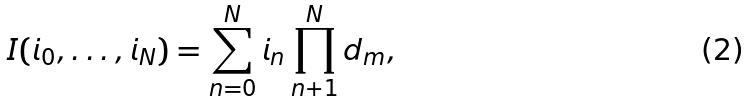Convert formula to latex. <formula><loc_0><loc_0><loc_500><loc_500>I ( i _ { 0 } , \dots , i _ { N } ) = \sum _ { n = 0 } ^ { N } i _ { n } \prod _ { n + 1 } ^ { N } d _ { m } ,</formula> 